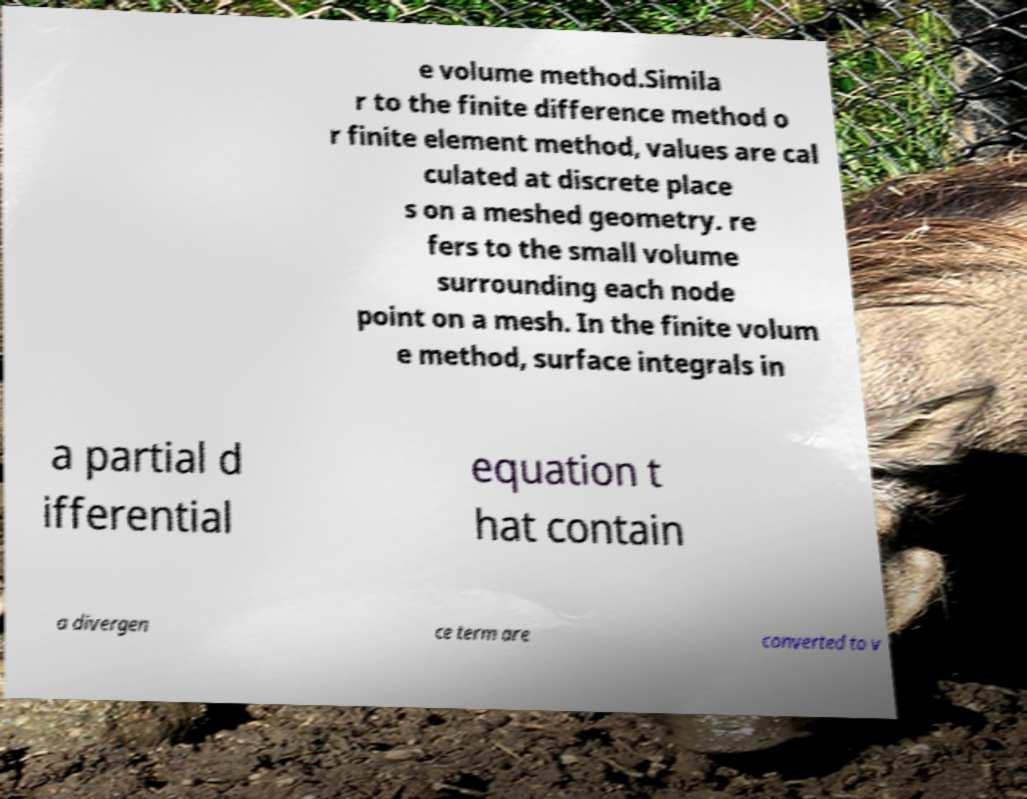Please identify and transcribe the text found in this image. e volume method.Simila r to the finite difference method o r finite element method, values are cal culated at discrete place s on a meshed geometry. re fers to the small volume surrounding each node point on a mesh. In the finite volum e method, surface integrals in a partial d ifferential equation t hat contain a divergen ce term are converted to v 